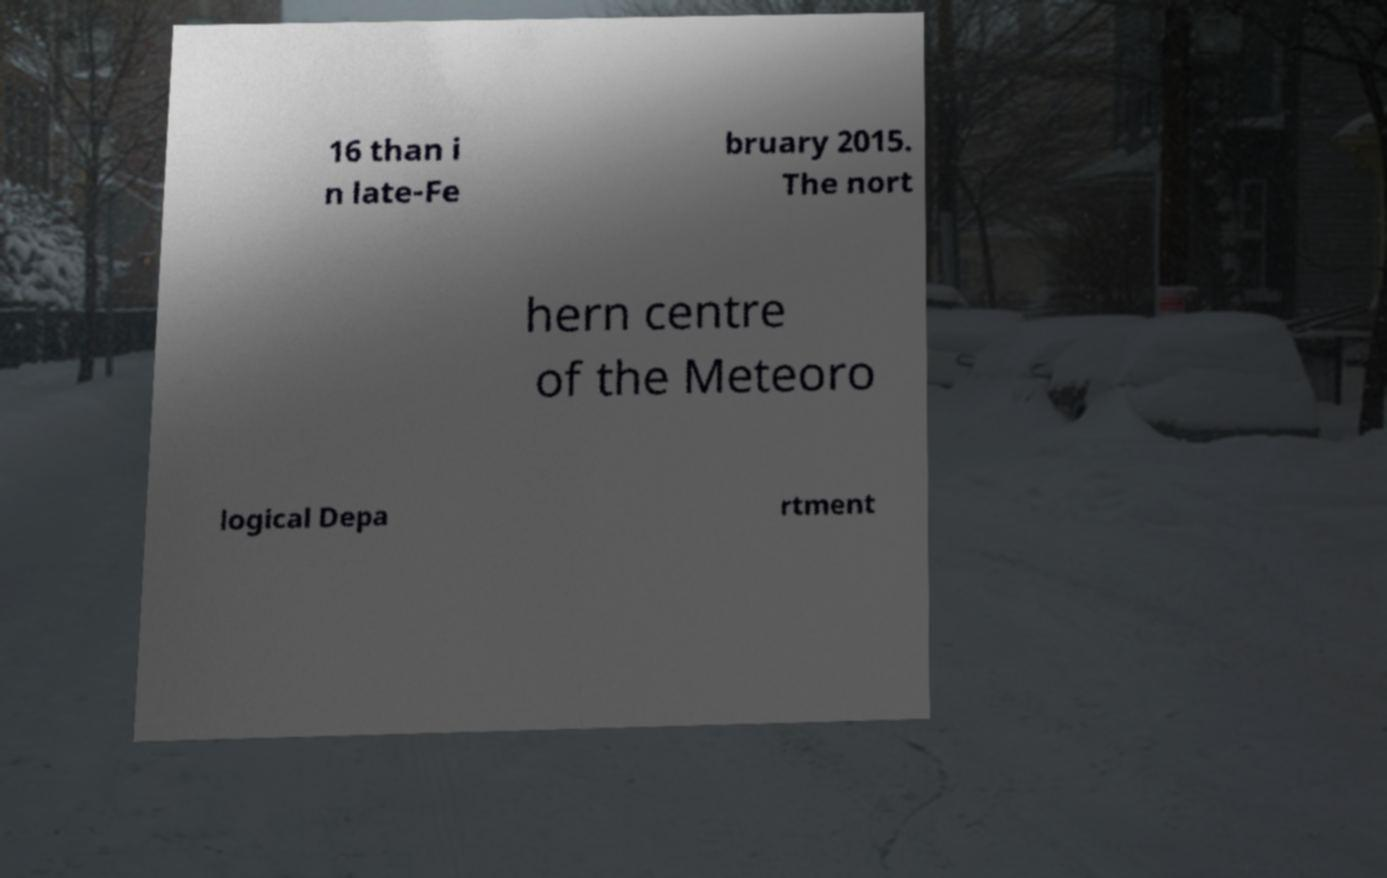Can you accurately transcribe the text from the provided image for me? 16 than i n late-Fe bruary 2015. The nort hern centre of the Meteoro logical Depa rtment 